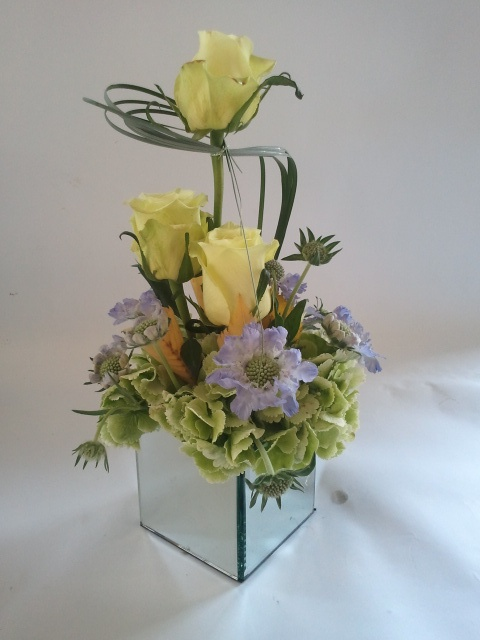Describe the objects in this image and their specific colors. I can see a vase in darkgray, lightblue, and black tones in this image. 